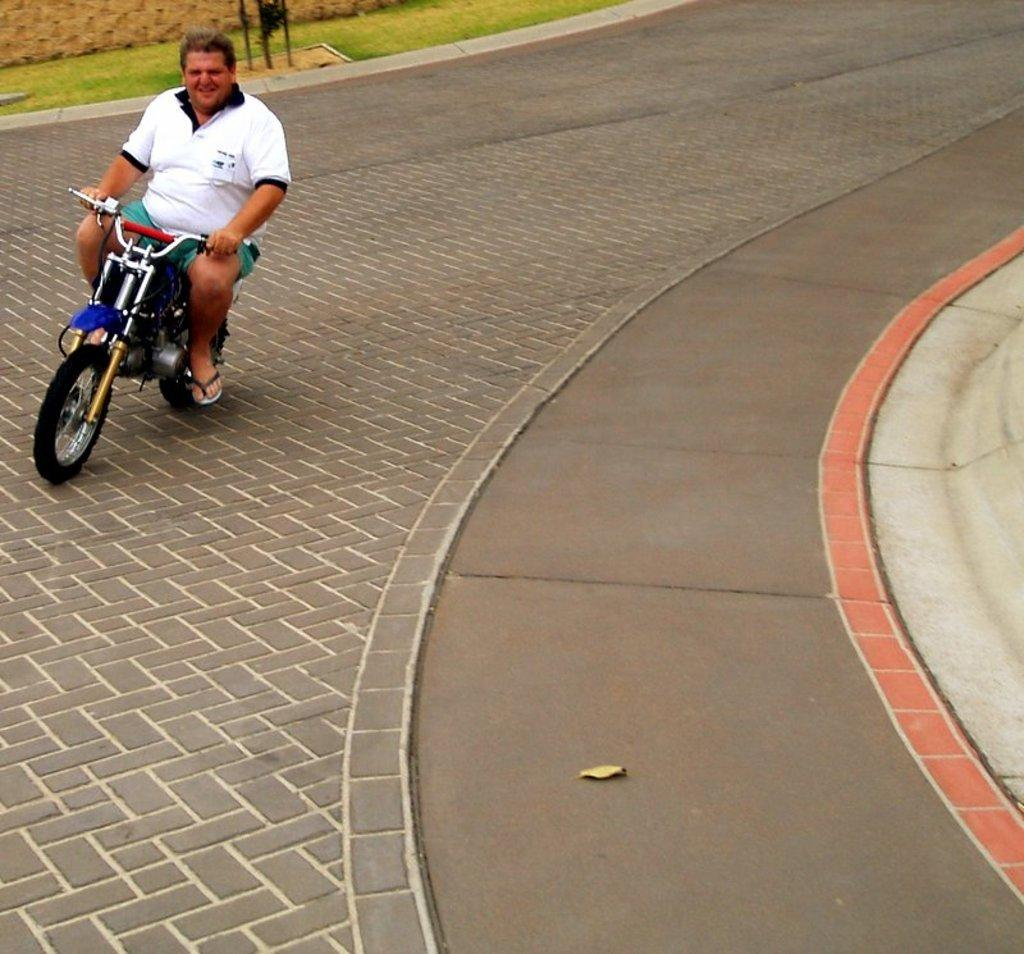What is the main subject of the image? There is a person in the image. What is the person wearing? The person is wearing a white shirt. What activity is the person engaged in? The person is riding a bike. Where is the bike located? The bike is on a road. What type of scent can be smelled coming from the cemetery in the image? There is no cemetery present in the image, so it's not possible to determine what, if any, scent might be smelled. What type of wood can be seen in the image? There is no wood present in the image. 